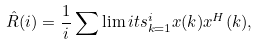<formula> <loc_0><loc_0><loc_500><loc_500>\hat { R } ( i ) = \frac { 1 } { i } \sum \lim i t s _ { k = 1 } ^ { i } { x } ( k ) { { x } ^ { H } } ( k ) ,</formula> 